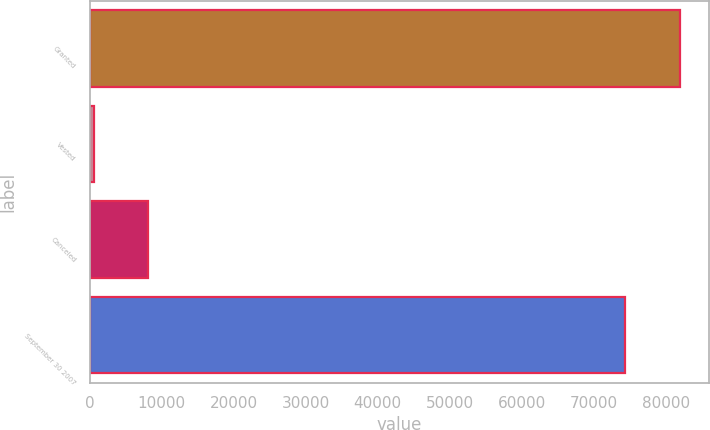Convert chart to OTSL. <chart><loc_0><loc_0><loc_500><loc_500><bar_chart><fcel>Granted<fcel>Vested<fcel>Canceled<fcel>September 30 2007<nl><fcel>81931.1<fcel>549<fcel>8079.1<fcel>74401<nl></chart> 